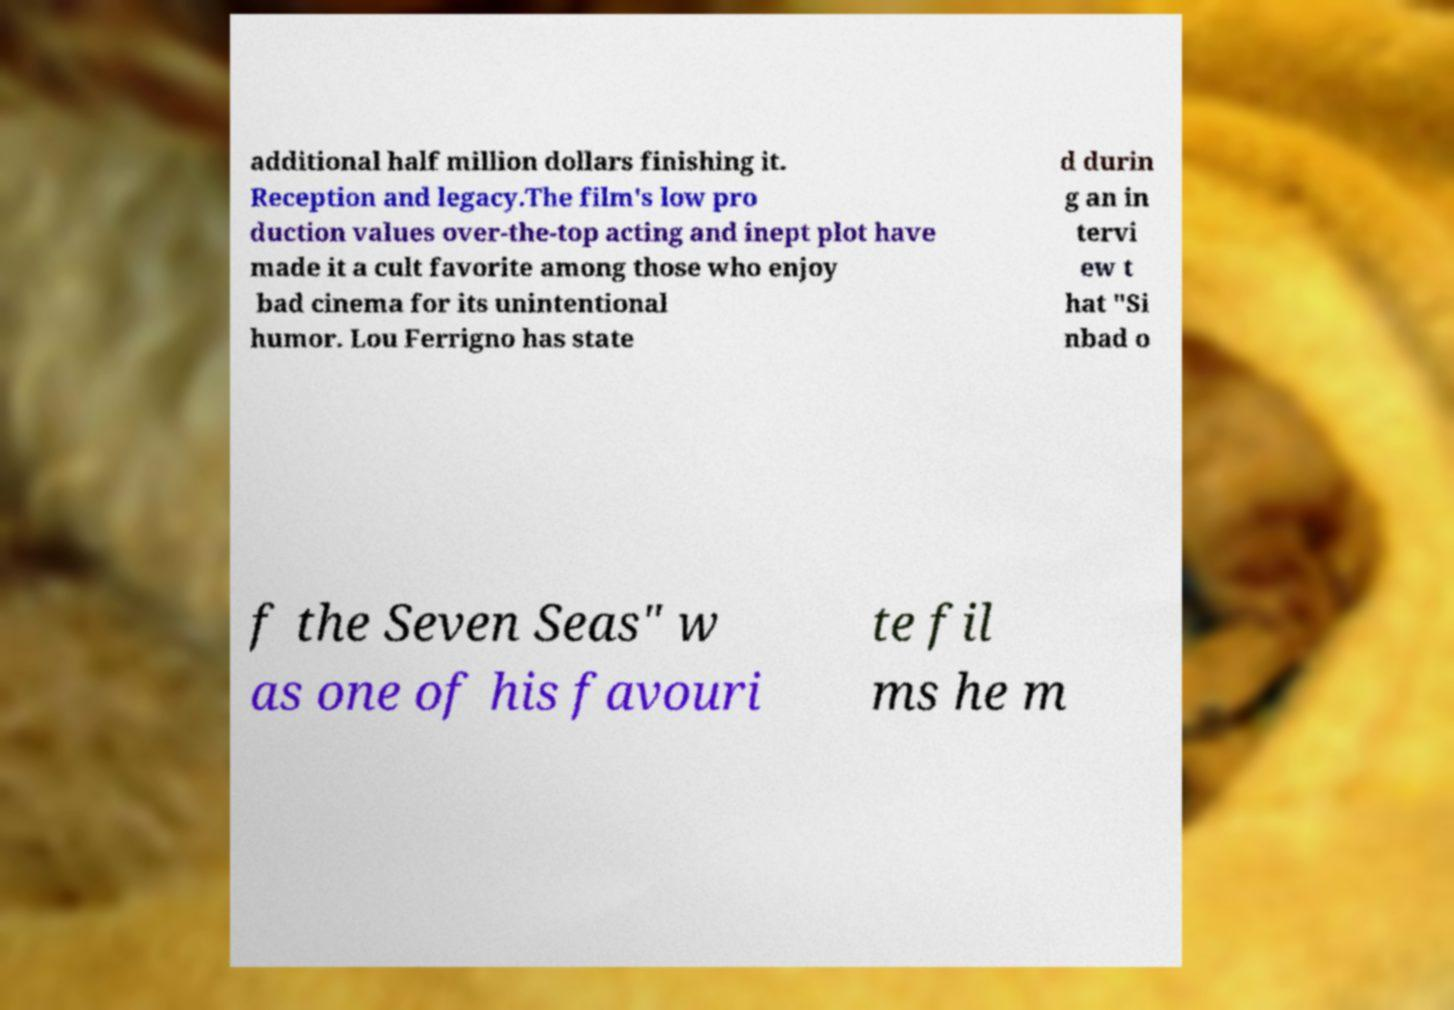Please identify and transcribe the text found in this image. additional half million dollars finishing it. Reception and legacy.The film's low pro duction values over-the-top acting and inept plot have made it a cult favorite among those who enjoy bad cinema for its unintentional humor. Lou Ferrigno has state d durin g an in tervi ew t hat "Si nbad o f the Seven Seas" w as one of his favouri te fil ms he m 